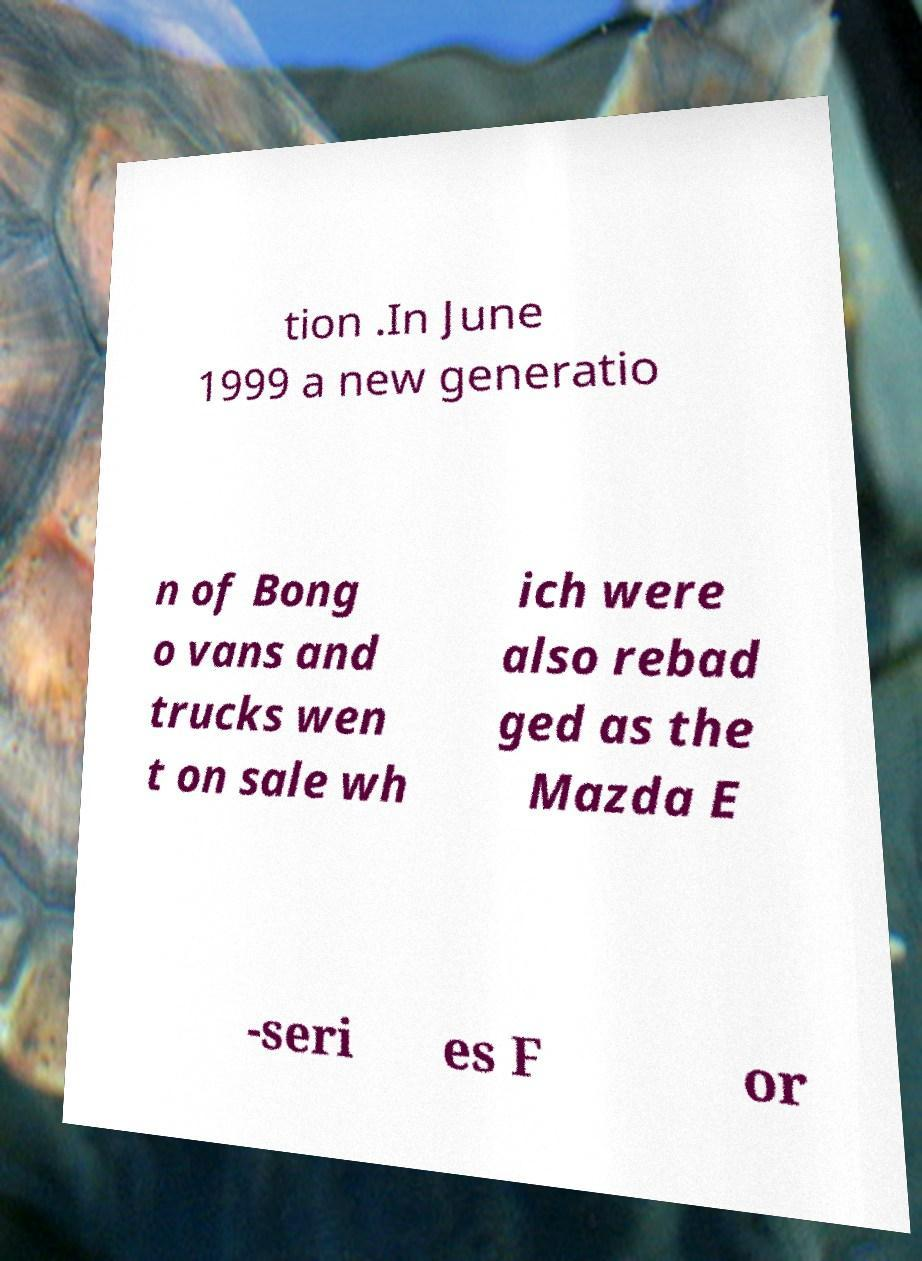There's text embedded in this image that I need extracted. Can you transcribe it verbatim? tion .In June 1999 a new generatio n of Bong o vans and trucks wen t on sale wh ich were also rebad ged as the Mazda E -seri es F or 